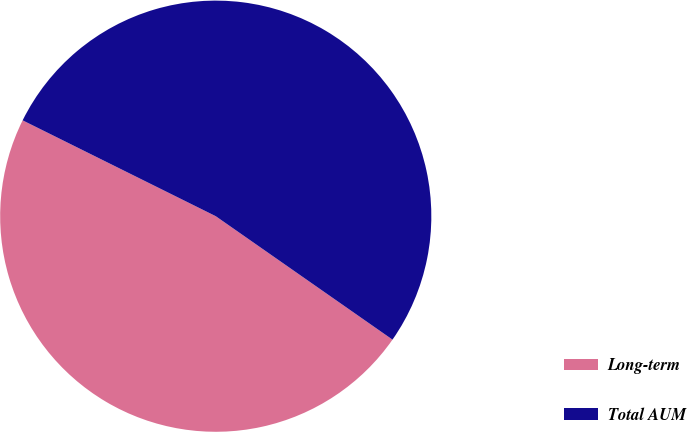<chart> <loc_0><loc_0><loc_500><loc_500><pie_chart><fcel>Long-term<fcel>Total AUM<nl><fcel>47.63%<fcel>52.37%<nl></chart> 